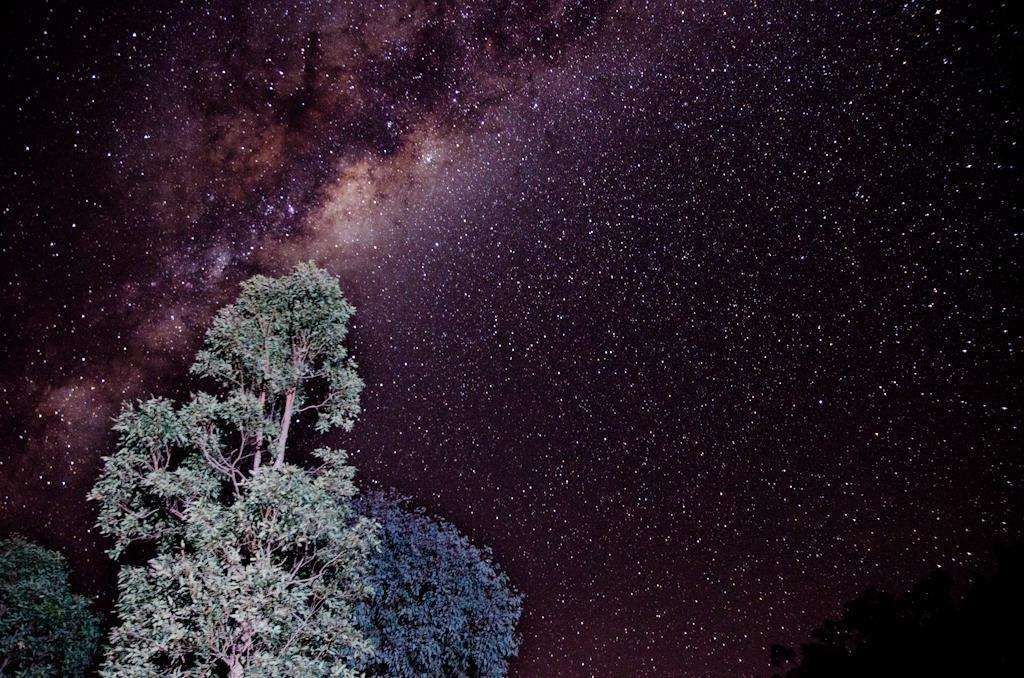What time of day was the image taken? The image was taken at night. What can be seen at the bottom left of the image? There are trees. What is visible in the background of the image? The sky with stars is visible in the background of the image. What type of soup is being served in the image? There is no soup present in the image. Can you provide a statement about the weather conditions during the time the image was taken? The provided facts do not mention any information about the weather conditions during the time the image was taken. 